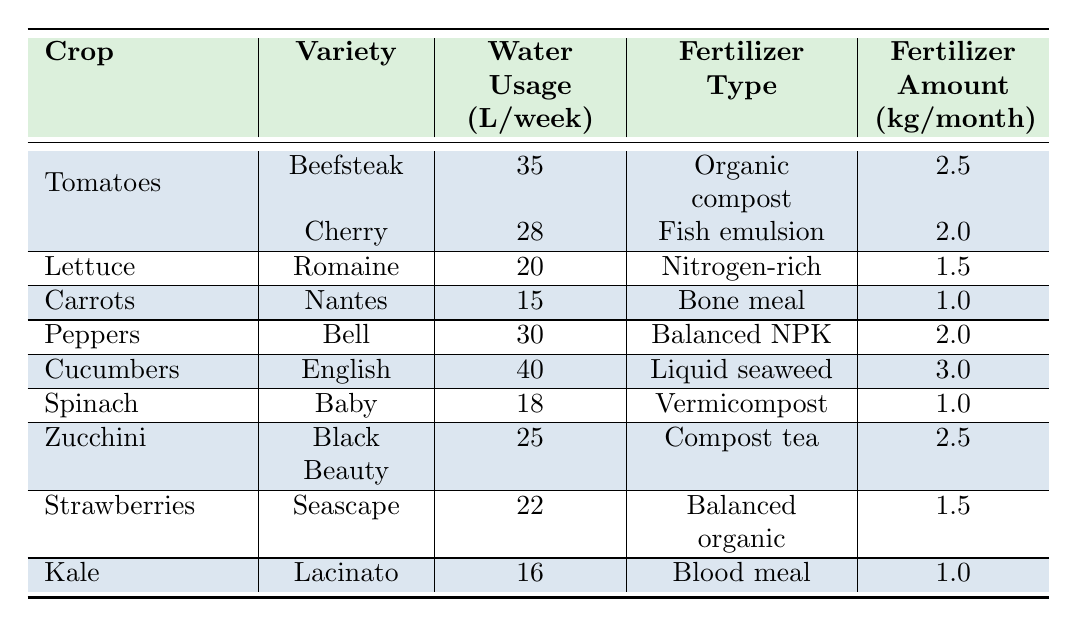What crop has the highest water usage per week? By reviewing the water usage for each crop listed in the table, I see that Cucumbers, with a value of 40 liters per week, has the highest water usage compared to all other crops.
Answer: Cucumbers Which fertilizer does Lettuce (Romaine) use? The table lists the fertilizer type for Lettuce (Romaine) as Nitrogen-rich.
Answer: Nitrogen-rich What is the total monthly fertilizer amount for all Tomato varieties? The fertilizer amounts for the Tomato varieties are 2.5 kg for Beefsteak and 2.0 kg for Cherry, when summed (2.5 + 2.0), the total monthly fertilizer amount for all Tomato varieties is 4.5 kg.
Answer: 4.5 kg Is the water usage for Zucchini higher than that for Kale? Zucchini uses 25 liters per week while Kale uses 16 liters per week. Since 25 is greater than 16, the statement is true.
Answer: Yes What is the average water usage per week for the different crops? To find the average, I first sum the weekly water usage values: 35 + 28 + 20 + 15 + 30 + 40 + 18 + 25 + 22 + 16 =  239 liters. There are 10 crops, so averaging gives 239/10, resulting in 23.9 liters per week.
Answer: 23.9 liters Which crop requires the least fertilizer amount per month? Carrots uses 1.0 kg per month, which is the least when compared to all other crops listed in the table.
Answer: Carrots How many crops have a water usage of 20 liters per week or more? By examining the table, I see that the crops with water usage of 20 liters per week or more are Tomatoes (Beefsteak, Cherry), Lettuce, Peppers, Cucumbers, and Zucchini, totaling 6 crops.
Answer: 6 What is the difference in water usage between Cucumbers and Spinach? Cucumbers use 40 liters per week, while Spinach uses 18 liters per week. The difference is calculated as 40 - 18 = 22 liters.
Answer: 22 liters Are all fertilizers used in the table organic? Upon reviewing, not all listed fertilizers are organic; for instance, Balanced NPK and Bone meal are not labeled organic, making the statement false.
Answer: No 